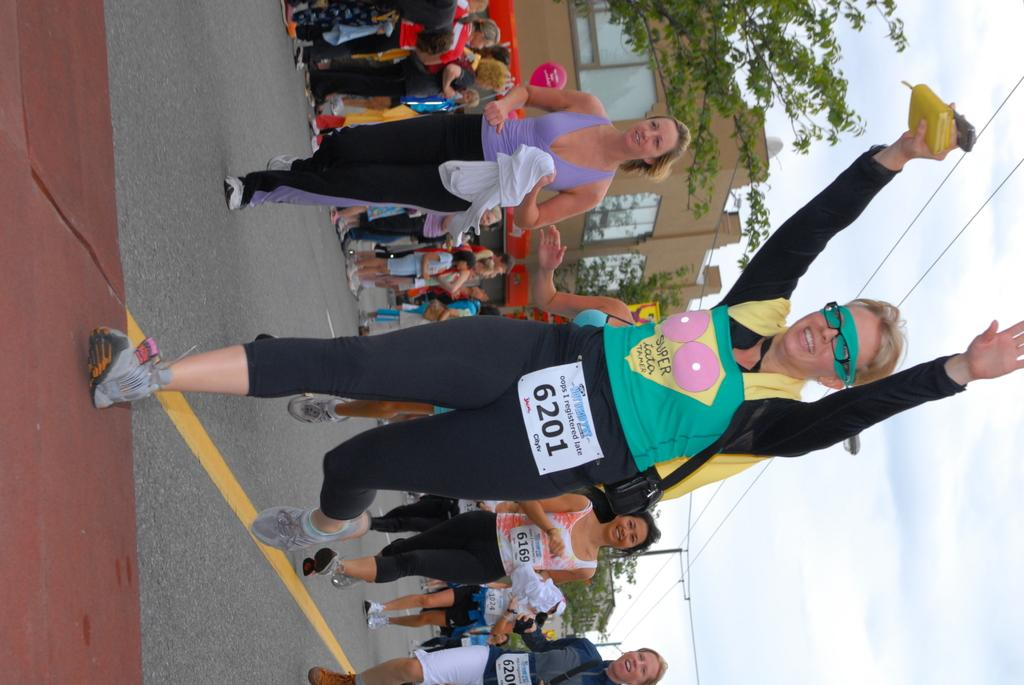What can be seen on the road in the image? There are people visible on the road in the image. What type of vegetation is present beside the road? There are trees beside the road. What type of structures can be seen in the image? There are buildings visible in the image. What is visible on the right side of the image? The sky is visible on the right side of the image. What type of infrastructure is present in the image? Power line cables are visible in the image. What type of harmony is being practiced by the people on the road in the image? There is no indication of any harmony practice in the image; it simply shows people on the road. Can you see any steam coming from the buildings in the image? There is no steam visible in the image. 